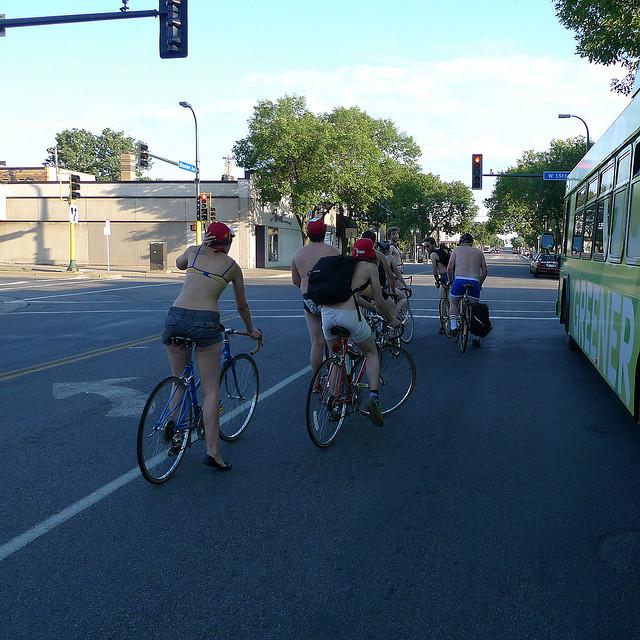Is anyone in the turning lane?
Concise answer only. No. In which direction is the arrow of the street pointing?
Write a very short answer. Left. Are these bikers wearing shirts?
Short answer required. No. 